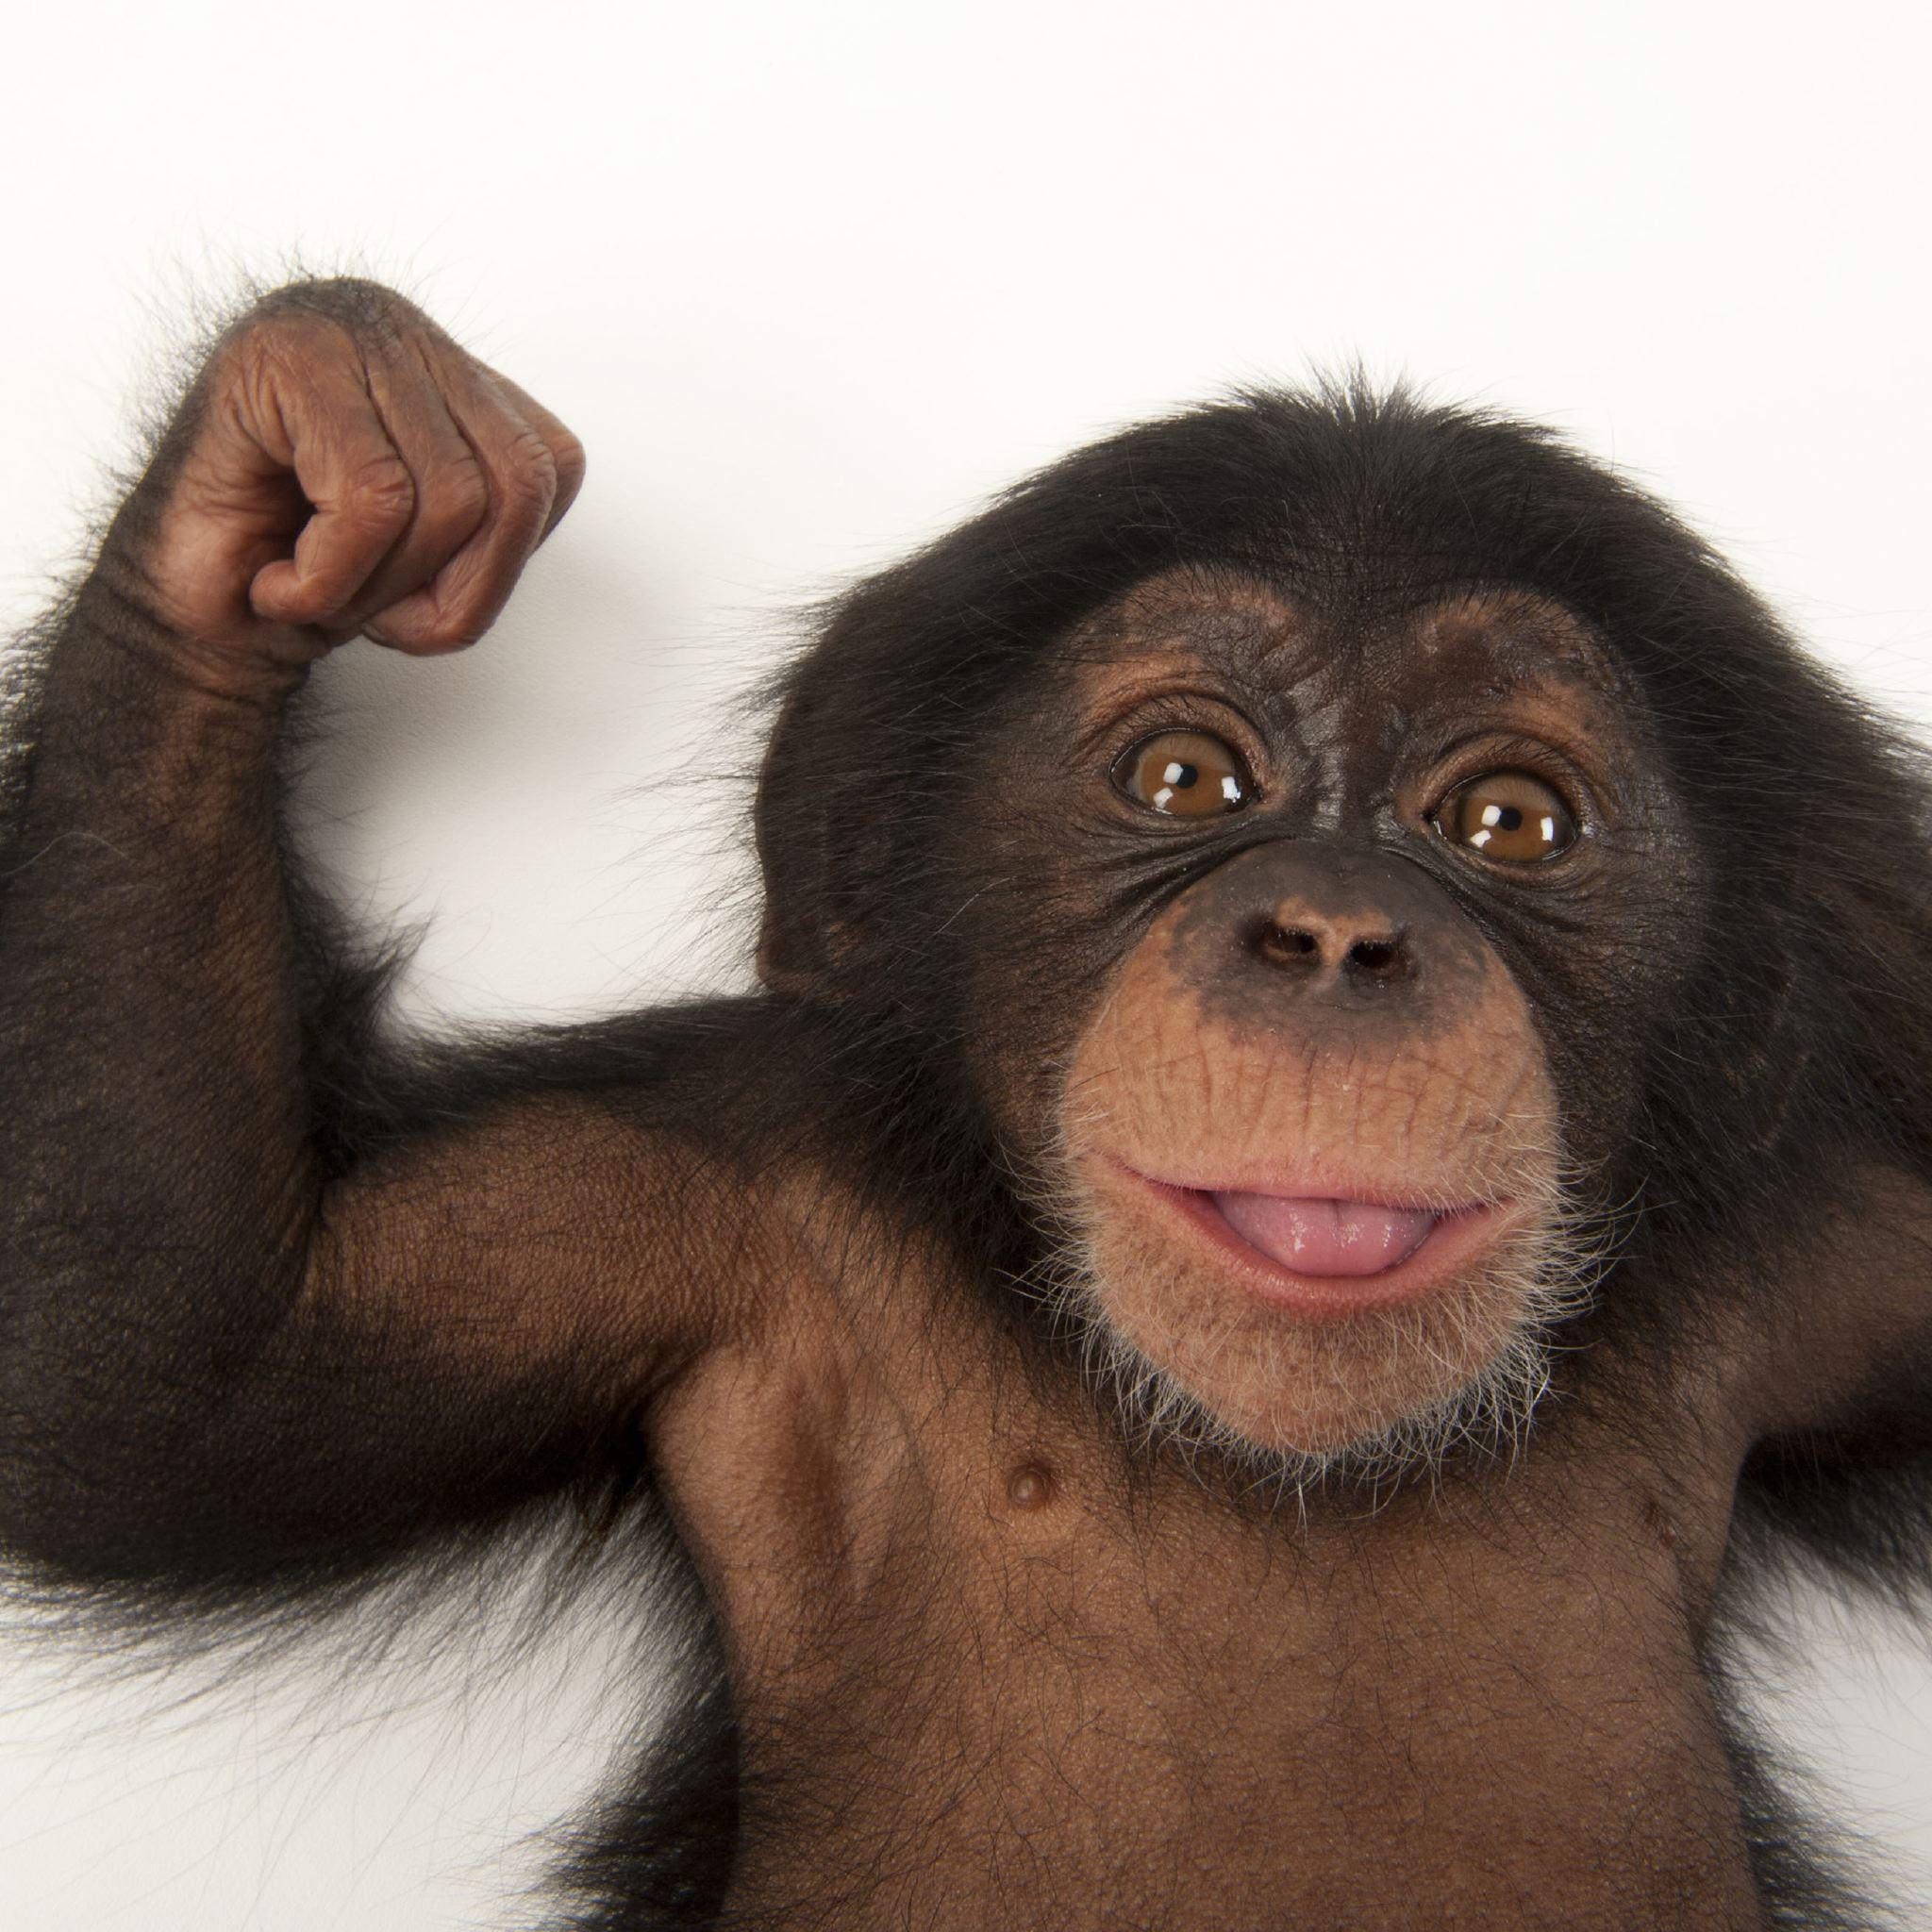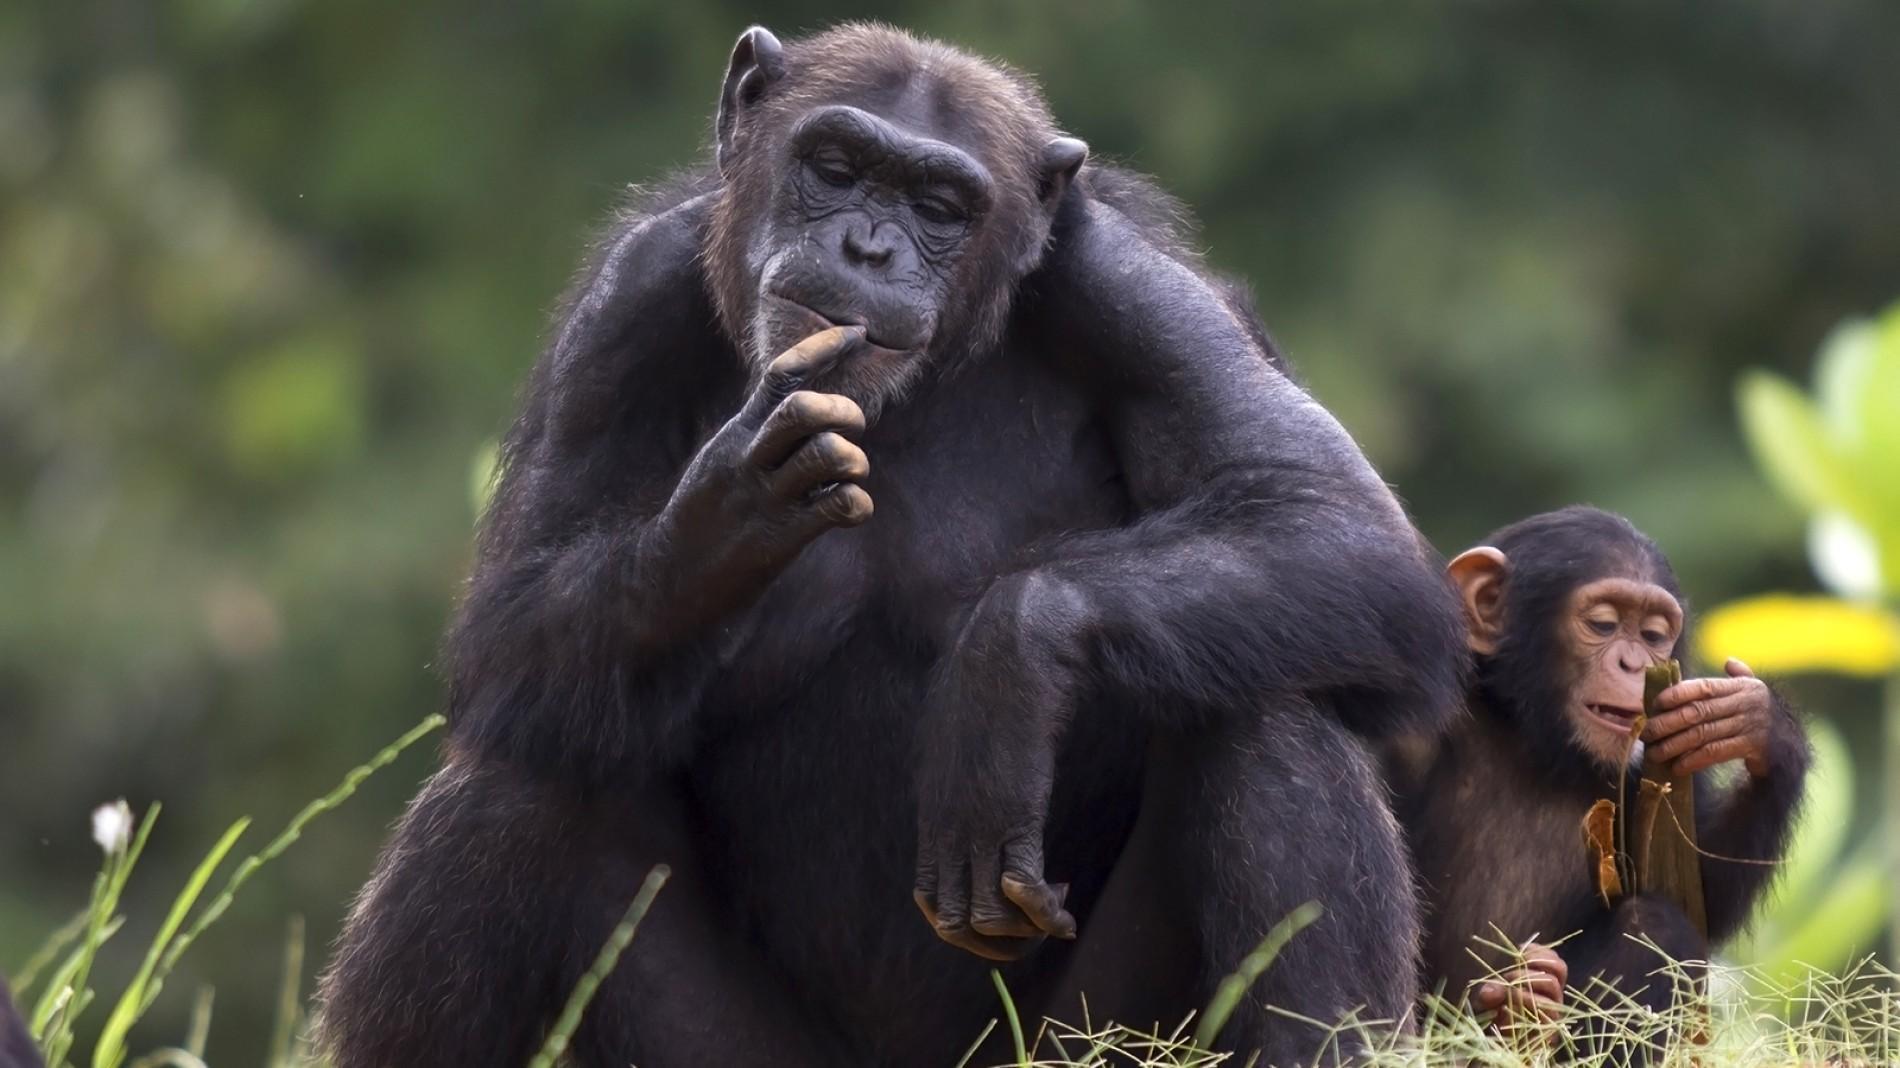The first image is the image on the left, the second image is the image on the right. Analyze the images presented: Is the assertion "There are two monkeys in the image on the right." valid? Answer yes or no. Yes. 